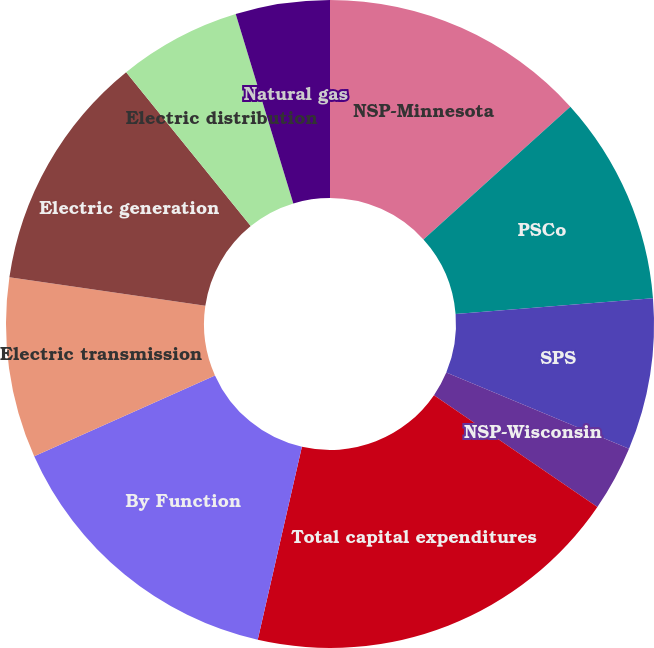Convert chart to OTSL. <chart><loc_0><loc_0><loc_500><loc_500><pie_chart><fcel>NSP-Minnesota<fcel>PSCo<fcel>SPS<fcel>NSP-Wisconsin<fcel>Total capital expenditures<fcel>By Function<fcel>Electric transmission<fcel>Electric generation<fcel>Electric distribution<fcel>Natural gas<nl><fcel>13.3%<fcel>10.43%<fcel>7.56%<fcel>3.26%<fcel>19.03%<fcel>14.73%<fcel>9.0%<fcel>11.86%<fcel>6.13%<fcel>4.7%<nl></chart> 